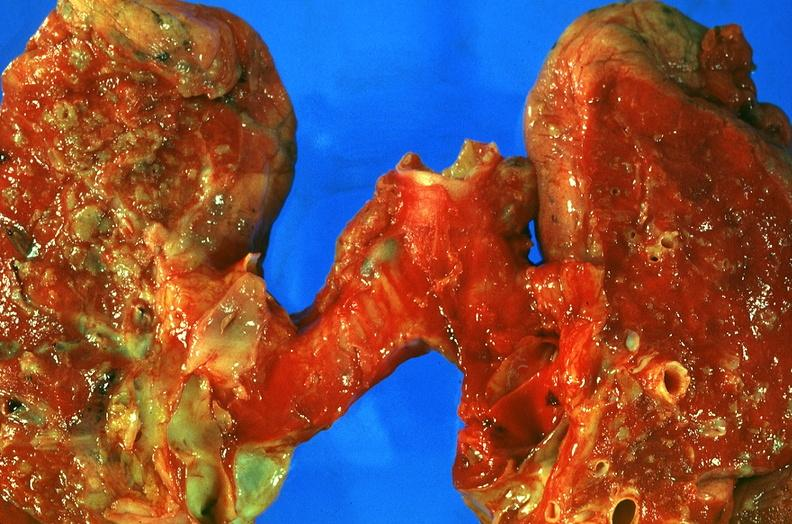s respiratory present?
Answer the question using a single word or phrase. Yes 